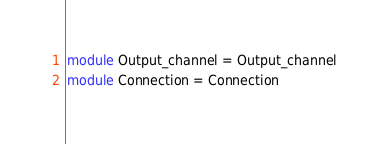<code> <loc_0><loc_0><loc_500><loc_500><_OCaml_>module Output_channel = Output_channel
module Connection = Connection
</code> 